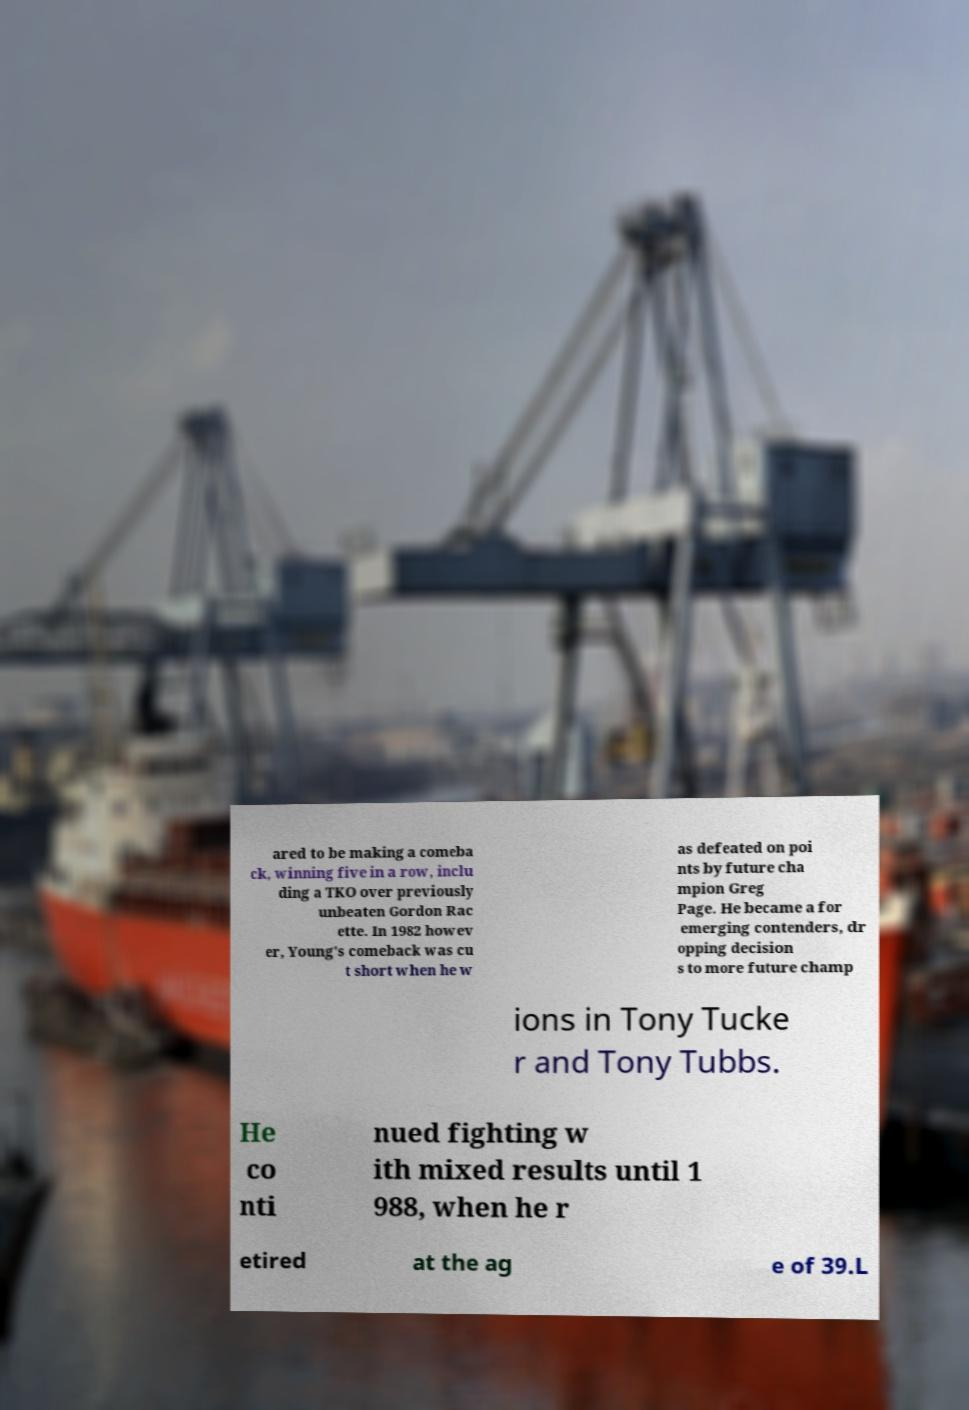Please read and relay the text visible in this image. What does it say? ared to be making a comeba ck, winning five in a row, inclu ding a TKO over previously unbeaten Gordon Rac ette. In 1982 howev er, Young's comeback was cu t short when he w as defeated on poi nts by future cha mpion Greg Page. He became a for emerging contenders, dr opping decision s to more future champ ions in Tony Tucke r and Tony Tubbs. He co nti nued fighting w ith mixed results until 1 988, when he r etired at the ag e of 39.L 